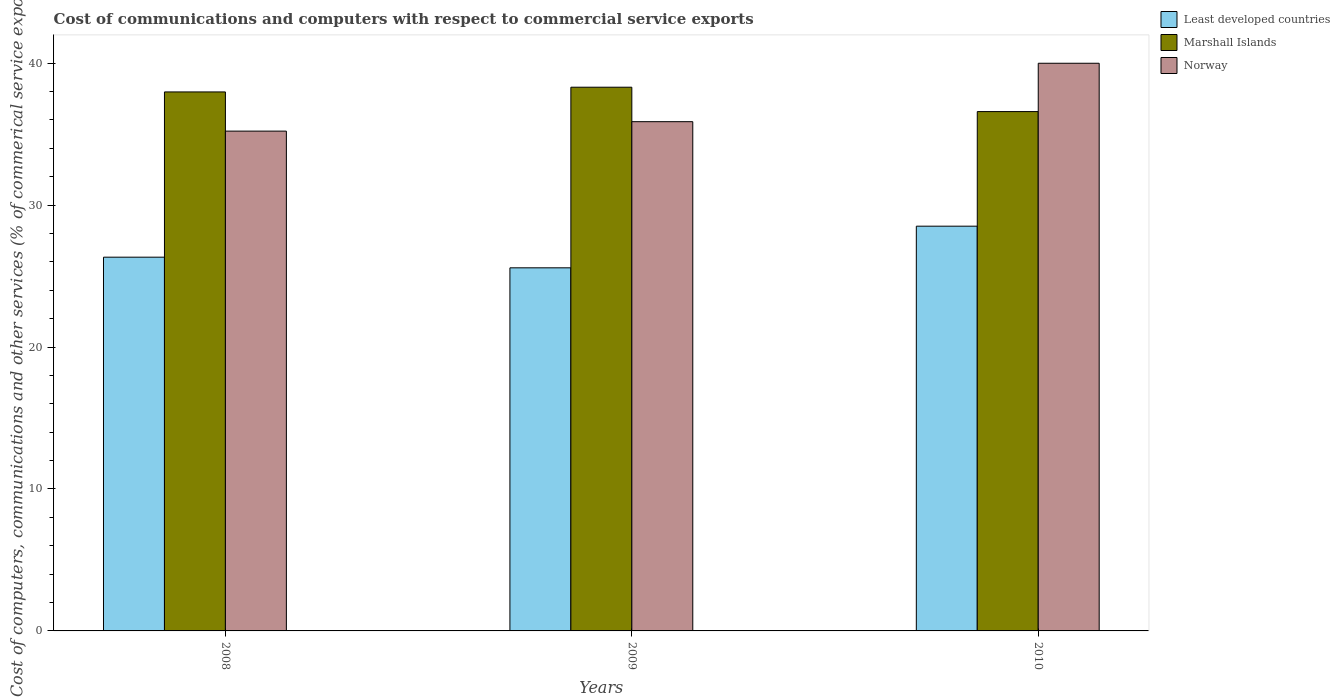How many groups of bars are there?
Your answer should be very brief. 3. Are the number of bars on each tick of the X-axis equal?
Make the answer very short. Yes. How many bars are there on the 3rd tick from the left?
Your response must be concise. 3. What is the label of the 2nd group of bars from the left?
Your answer should be very brief. 2009. What is the cost of communications and computers in Least developed countries in 2010?
Ensure brevity in your answer.  28.52. Across all years, what is the maximum cost of communications and computers in Least developed countries?
Your response must be concise. 28.52. Across all years, what is the minimum cost of communications and computers in Marshall Islands?
Ensure brevity in your answer.  36.59. In which year was the cost of communications and computers in Least developed countries maximum?
Ensure brevity in your answer.  2010. In which year was the cost of communications and computers in Least developed countries minimum?
Give a very brief answer. 2009. What is the total cost of communications and computers in Least developed countries in the graph?
Provide a succinct answer. 80.43. What is the difference between the cost of communications and computers in Norway in 2008 and that in 2009?
Your response must be concise. -0.67. What is the difference between the cost of communications and computers in Marshall Islands in 2010 and the cost of communications and computers in Least developed countries in 2009?
Keep it short and to the point. 11.01. What is the average cost of communications and computers in Marshall Islands per year?
Offer a terse response. 37.62. In the year 2008, what is the difference between the cost of communications and computers in Norway and cost of communications and computers in Least developed countries?
Your response must be concise. 8.88. What is the ratio of the cost of communications and computers in Norway in 2008 to that in 2009?
Your response must be concise. 0.98. Is the cost of communications and computers in Least developed countries in 2009 less than that in 2010?
Your answer should be compact. Yes. What is the difference between the highest and the second highest cost of communications and computers in Marshall Islands?
Offer a very short reply. 0.33. What is the difference between the highest and the lowest cost of communications and computers in Marshall Islands?
Your response must be concise. 1.72. In how many years, is the cost of communications and computers in Marshall Islands greater than the average cost of communications and computers in Marshall Islands taken over all years?
Your response must be concise. 2. What does the 2nd bar from the left in 2008 represents?
Give a very brief answer. Marshall Islands. What does the 2nd bar from the right in 2009 represents?
Your response must be concise. Marshall Islands. How many bars are there?
Your response must be concise. 9. How many years are there in the graph?
Provide a succinct answer. 3. Are the values on the major ticks of Y-axis written in scientific E-notation?
Provide a short and direct response. No. Does the graph contain grids?
Your answer should be compact. No. How many legend labels are there?
Offer a terse response. 3. How are the legend labels stacked?
Provide a short and direct response. Vertical. What is the title of the graph?
Your answer should be very brief. Cost of communications and computers with respect to commercial service exports. What is the label or title of the X-axis?
Make the answer very short. Years. What is the label or title of the Y-axis?
Make the answer very short. Cost of computers, communications and other services (% of commerical service exports). What is the Cost of computers, communications and other services (% of commerical service exports) of Least developed countries in 2008?
Provide a short and direct response. 26.33. What is the Cost of computers, communications and other services (% of commerical service exports) in Marshall Islands in 2008?
Your answer should be very brief. 37.97. What is the Cost of computers, communications and other services (% of commerical service exports) of Norway in 2008?
Make the answer very short. 35.21. What is the Cost of computers, communications and other services (% of commerical service exports) of Least developed countries in 2009?
Provide a short and direct response. 25.58. What is the Cost of computers, communications and other services (% of commerical service exports) in Marshall Islands in 2009?
Your answer should be compact. 38.31. What is the Cost of computers, communications and other services (% of commerical service exports) in Norway in 2009?
Give a very brief answer. 35.88. What is the Cost of computers, communications and other services (% of commerical service exports) of Least developed countries in 2010?
Make the answer very short. 28.52. What is the Cost of computers, communications and other services (% of commerical service exports) of Marshall Islands in 2010?
Ensure brevity in your answer.  36.59. What is the Cost of computers, communications and other services (% of commerical service exports) in Norway in 2010?
Make the answer very short. 39.99. Across all years, what is the maximum Cost of computers, communications and other services (% of commerical service exports) of Least developed countries?
Make the answer very short. 28.52. Across all years, what is the maximum Cost of computers, communications and other services (% of commerical service exports) in Marshall Islands?
Give a very brief answer. 38.31. Across all years, what is the maximum Cost of computers, communications and other services (% of commerical service exports) of Norway?
Ensure brevity in your answer.  39.99. Across all years, what is the minimum Cost of computers, communications and other services (% of commerical service exports) of Least developed countries?
Keep it short and to the point. 25.58. Across all years, what is the minimum Cost of computers, communications and other services (% of commerical service exports) of Marshall Islands?
Offer a terse response. 36.59. Across all years, what is the minimum Cost of computers, communications and other services (% of commerical service exports) of Norway?
Your response must be concise. 35.21. What is the total Cost of computers, communications and other services (% of commerical service exports) of Least developed countries in the graph?
Your response must be concise. 80.43. What is the total Cost of computers, communications and other services (% of commerical service exports) of Marshall Islands in the graph?
Offer a terse response. 112.87. What is the total Cost of computers, communications and other services (% of commerical service exports) in Norway in the graph?
Keep it short and to the point. 111.08. What is the difference between the Cost of computers, communications and other services (% of commerical service exports) of Least developed countries in 2008 and that in 2009?
Your response must be concise. 0.75. What is the difference between the Cost of computers, communications and other services (% of commerical service exports) of Marshall Islands in 2008 and that in 2009?
Your response must be concise. -0.33. What is the difference between the Cost of computers, communications and other services (% of commerical service exports) in Norway in 2008 and that in 2009?
Your response must be concise. -0.67. What is the difference between the Cost of computers, communications and other services (% of commerical service exports) of Least developed countries in 2008 and that in 2010?
Provide a short and direct response. -2.18. What is the difference between the Cost of computers, communications and other services (% of commerical service exports) in Marshall Islands in 2008 and that in 2010?
Ensure brevity in your answer.  1.38. What is the difference between the Cost of computers, communications and other services (% of commerical service exports) in Norway in 2008 and that in 2010?
Keep it short and to the point. -4.78. What is the difference between the Cost of computers, communications and other services (% of commerical service exports) of Least developed countries in 2009 and that in 2010?
Offer a terse response. -2.93. What is the difference between the Cost of computers, communications and other services (% of commerical service exports) in Marshall Islands in 2009 and that in 2010?
Ensure brevity in your answer.  1.72. What is the difference between the Cost of computers, communications and other services (% of commerical service exports) in Norway in 2009 and that in 2010?
Give a very brief answer. -4.12. What is the difference between the Cost of computers, communications and other services (% of commerical service exports) of Least developed countries in 2008 and the Cost of computers, communications and other services (% of commerical service exports) of Marshall Islands in 2009?
Offer a terse response. -11.98. What is the difference between the Cost of computers, communications and other services (% of commerical service exports) of Least developed countries in 2008 and the Cost of computers, communications and other services (% of commerical service exports) of Norway in 2009?
Your response must be concise. -9.55. What is the difference between the Cost of computers, communications and other services (% of commerical service exports) in Marshall Islands in 2008 and the Cost of computers, communications and other services (% of commerical service exports) in Norway in 2009?
Make the answer very short. 2.1. What is the difference between the Cost of computers, communications and other services (% of commerical service exports) in Least developed countries in 2008 and the Cost of computers, communications and other services (% of commerical service exports) in Marshall Islands in 2010?
Give a very brief answer. -10.26. What is the difference between the Cost of computers, communications and other services (% of commerical service exports) in Least developed countries in 2008 and the Cost of computers, communications and other services (% of commerical service exports) in Norway in 2010?
Ensure brevity in your answer.  -13.66. What is the difference between the Cost of computers, communications and other services (% of commerical service exports) of Marshall Islands in 2008 and the Cost of computers, communications and other services (% of commerical service exports) of Norway in 2010?
Offer a terse response. -2.02. What is the difference between the Cost of computers, communications and other services (% of commerical service exports) in Least developed countries in 2009 and the Cost of computers, communications and other services (% of commerical service exports) in Marshall Islands in 2010?
Keep it short and to the point. -11.01. What is the difference between the Cost of computers, communications and other services (% of commerical service exports) of Least developed countries in 2009 and the Cost of computers, communications and other services (% of commerical service exports) of Norway in 2010?
Offer a very short reply. -14.41. What is the difference between the Cost of computers, communications and other services (% of commerical service exports) in Marshall Islands in 2009 and the Cost of computers, communications and other services (% of commerical service exports) in Norway in 2010?
Your response must be concise. -1.69. What is the average Cost of computers, communications and other services (% of commerical service exports) in Least developed countries per year?
Your response must be concise. 26.81. What is the average Cost of computers, communications and other services (% of commerical service exports) in Marshall Islands per year?
Your response must be concise. 37.62. What is the average Cost of computers, communications and other services (% of commerical service exports) in Norway per year?
Provide a short and direct response. 37.03. In the year 2008, what is the difference between the Cost of computers, communications and other services (% of commerical service exports) in Least developed countries and Cost of computers, communications and other services (% of commerical service exports) in Marshall Islands?
Your response must be concise. -11.64. In the year 2008, what is the difference between the Cost of computers, communications and other services (% of commerical service exports) in Least developed countries and Cost of computers, communications and other services (% of commerical service exports) in Norway?
Your answer should be very brief. -8.88. In the year 2008, what is the difference between the Cost of computers, communications and other services (% of commerical service exports) in Marshall Islands and Cost of computers, communications and other services (% of commerical service exports) in Norway?
Make the answer very short. 2.76. In the year 2009, what is the difference between the Cost of computers, communications and other services (% of commerical service exports) of Least developed countries and Cost of computers, communications and other services (% of commerical service exports) of Marshall Islands?
Make the answer very short. -12.72. In the year 2009, what is the difference between the Cost of computers, communications and other services (% of commerical service exports) of Least developed countries and Cost of computers, communications and other services (% of commerical service exports) of Norway?
Your answer should be compact. -10.3. In the year 2009, what is the difference between the Cost of computers, communications and other services (% of commerical service exports) in Marshall Islands and Cost of computers, communications and other services (% of commerical service exports) in Norway?
Offer a terse response. 2.43. In the year 2010, what is the difference between the Cost of computers, communications and other services (% of commerical service exports) in Least developed countries and Cost of computers, communications and other services (% of commerical service exports) in Marshall Islands?
Your response must be concise. -8.07. In the year 2010, what is the difference between the Cost of computers, communications and other services (% of commerical service exports) of Least developed countries and Cost of computers, communications and other services (% of commerical service exports) of Norway?
Offer a very short reply. -11.48. In the year 2010, what is the difference between the Cost of computers, communications and other services (% of commerical service exports) in Marshall Islands and Cost of computers, communications and other services (% of commerical service exports) in Norway?
Offer a terse response. -3.41. What is the ratio of the Cost of computers, communications and other services (% of commerical service exports) in Least developed countries in 2008 to that in 2009?
Provide a succinct answer. 1.03. What is the ratio of the Cost of computers, communications and other services (% of commerical service exports) in Marshall Islands in 2008 to that in 2009?
Make the answer very short. 0.99. What is the ratio of the Cost of computers, communications and other services (% of commerical service exports) of Norway in 2008 to that in 2009?
Make the answer very short. 0.98. What is the ratio of the Cost of computers, communications and other services (% of commerical service exports) of Least developed countries in 2008 to that in 2010?
Provide a succinct answer. 0.92. What is the ratio of the Cost of computers, communications and other services (% of commerical service exports) of Marshall Islands in 2008 to that in 2010?
Your answer should be compact. 1.04. What is the ratio of the Cost of computers, communications and other services (% of commerical service exports) of Norway in 2008 to that in 2010?
Provide a succinct answer. 0.88. What is the ratio of the Cost of computers, communications and other services (% of commerical service exports) of Least developed countries in 2009 to that in 2010?
Offer a very short reply. 0.9. What is the ratio of the Cost of computers, communications and other services (% of commerical service exports) in Marshall Islands in 2009 to that in 2010?
Provide a short and direct response. 1.05. What is the ratio of the Cost of computers, communications and other services (% of commerical service exports) in Norway in 2009 to that in 2010?
Offer a terse response. 0.9. What is the difference between the highest and the second highest Cost of computers, communications and other services (% of commerical service exports) in Least developed countries?
Make the answer very short. 2.18. What is the difference between the highest and the second highest Cost of computers, communications and other services (% of commerical service exports) of Marshall Islands?
Give a very brief answer. 0.33. What is the difference between the highest and the second highest Cost of computers, communications and other services (% of commerical service exports) in Norway?
Give a very brief answer. 4.12. What is the difference between the highest and the lowest Cost of computers, communications and other services (% of commerical service exports) in Least developed countries?
Keep it short and to the point. 2.93. What is the difference between the highest and the lowest Cost of computers, communications and other services (% of commerical service exports) in Marshall Islands?
Provide a succinct answer. 1.72. What is the difference between the highest and the lowest Cost of computers, communications and other services (% of commerical service exports) in Norway?
Offer a terse response. 4.78. 